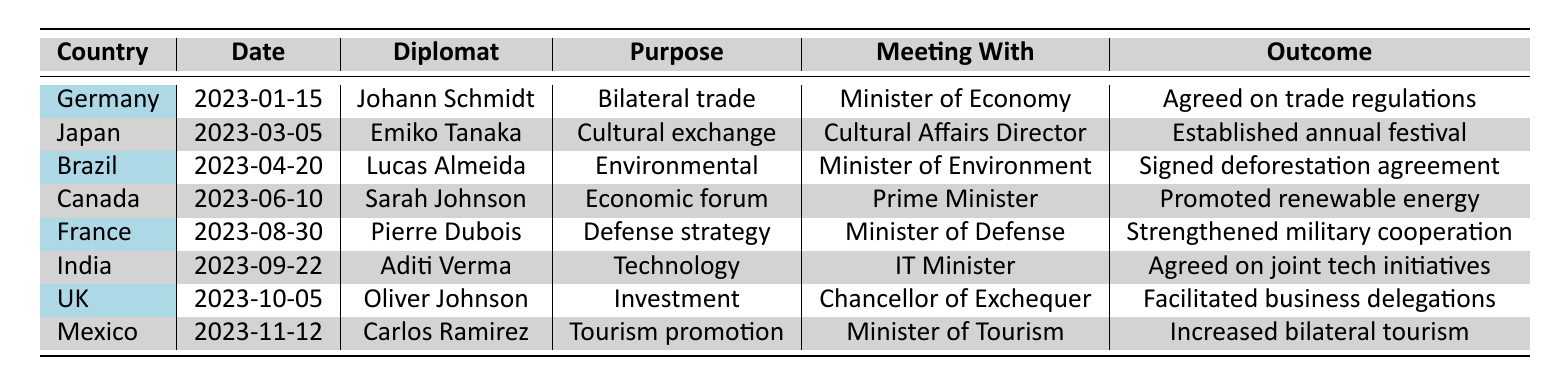What country did the diplomat Johann Schmidt visit? Johann Schmidt is listed in the table under the country of Germany, indicating he visited Germany.
Answer: Germany What was the purpose of Emiko Tanaka's diplomatic visit? The table states that Emiko Tanaka's purpose for her visit to Japan was for a cultural exchange program.
Answer: Cultural exchange program How many days did the visit to Canada last? According to the table, the duration of the visit to Canada by Sarah Johnson was 2 days.
Answer: 2 What was the outcome of the visit to Brazil? The table shows that the outcome of Lucas Almeida's visit to Brazil was the signing of an agreement on deforestation initiatives.
Answer: Signed agreement on deforestation initiatives Did Aditi Verma meet with the Minister of Information Technology? The table confirms that Aditi Verma met with the Minister of Information Technology during her visit to India.
Answer: Yes Which diplomat participated in the Economic forum in Canada? The table shows that Sarah Johnson was the diplomat who participated in the Economic forum in Canada.
Answer: Sarah Johnson What is the total duration of diplomatic visits logged in the table? The total duration is calculated by adding up all the duration days: 3 + 5 + 4 + 2 + 1 + 3 + 2 + 3 = 23 days.
Answer: 23 days How many different countries were visited in total? The table lists visits from eight different countries, each represented by a separate row.
Answer: 8 Which meeting resulted in increasing bilateral tourism efforts? According to the table, the meeting with the Minister of Tourism during Carlos Ramirez's visit to Mexico resulted in increased bilateral tourism efforts.
Answer: Meeting with the Minister of Tourism Which diplomat had the shortest duration of visit? The visit by Pierre Dubois to France lasted only 1 day, which is the shortest duration listed in the table.
Answer: Pierre Dubois 